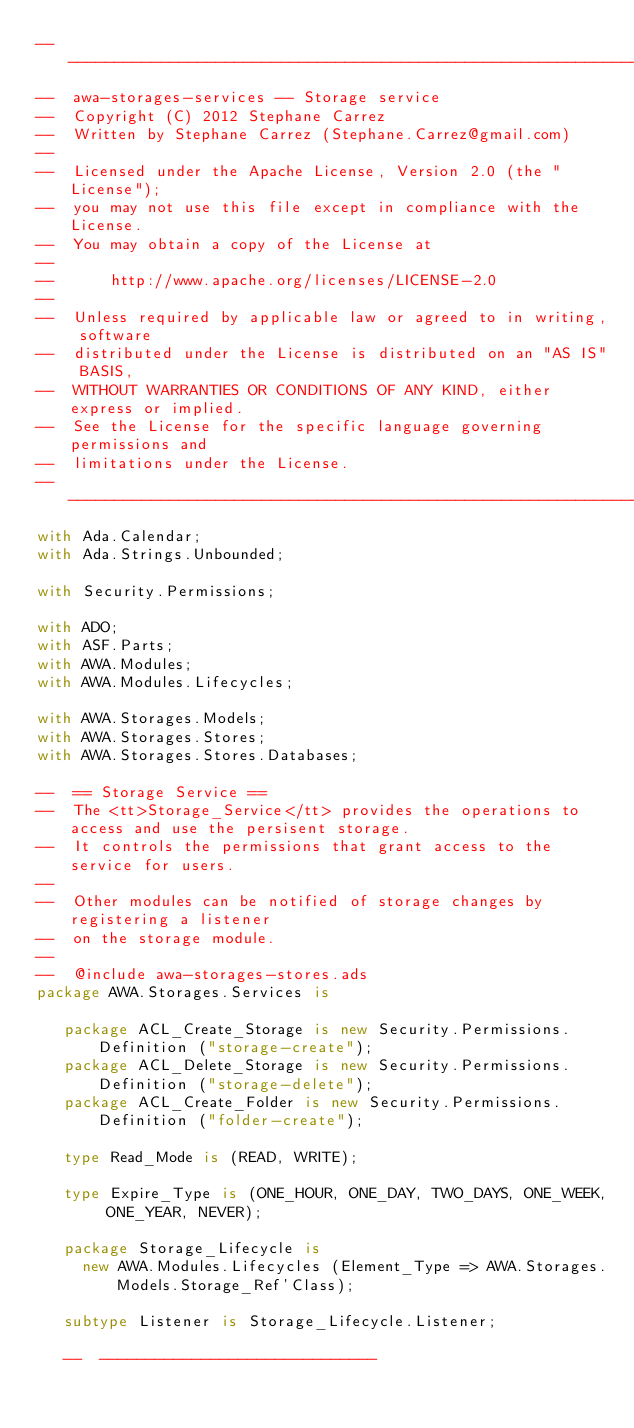<code> <loc_0><loc_0><loc_500><loc_500><_Ada_>-----------------------------------------------------------------------
--  awa-storages-services -- Storage service
--  Copyright (C) 2012 Stephane Carrez
--  Written by Stephane Carrez (Stephane.Carrez@gmail.com)
--
--  Licensed under the Apache License, Version 2.0 (the "License");
--  you may not use this file except in compliance with the License.
--  You may obtain a copy of the License at
--
--      http://www.apache.org/licenses/LICENSE-2.0
--
--  Unless required by applicable law or agreed to in writing, software
--  distributed under the License is distributed on an "AS IS" BASIS,
--  WITHOUT WARRANTIES OR CONDITIONS OF ANY KIND, either express or implied.
--  See the License for the specific language governing permissions and
--  limitations under the License.
-----------------------------------------------------------------------
with Ada.Calendar;
with Ada.Strings.Unbounded;

with Security.Permissions;

with ADO;
with ASF.Parts;
with AWA.Modules;
with AWA.Modules.Lifecycles;

with AWA.Storages.Models;
with AWA.Storages.Stores;
with AWA.Storages.Stores.Databases;

--  == Storage Service ==
--  The <tt>Storage_Service</tt> provides the operations to access and use the persisent storage.
--  It controls the permissions that grant access to the service for users.
--
--  Other modules can be notified of storage changes by registering a listener
--  on the storage module.
--
--  @include awa-storages-stores.ads
package AWA.Storages.Services is

   package ACL_Create_Storage is new Security.Permissions.Definition ("storage-create");
   package ACL_Delete_Storage is new Security.Permissions.Definition ("storage-delete");
   package ACL_Create_Folder is new Security.Permissions.Definition ("folder-create");

   type Read_Mode is (READ, WRITE);

   type Expire_Type is (ONE_HOUR, ONE_DAY, TWO_DAYS, ONE_WEEK, ONE_YEAR, NEVER);

   package Storage_Lifecycle is
     new AWA.Modules.Lifecycles (Element_Type => AWA.Storages.Models.Storage_Ref'Class);

   subtype Listener is Storage_Lifecycle.Listener;

   --  ------------------------------</code> 